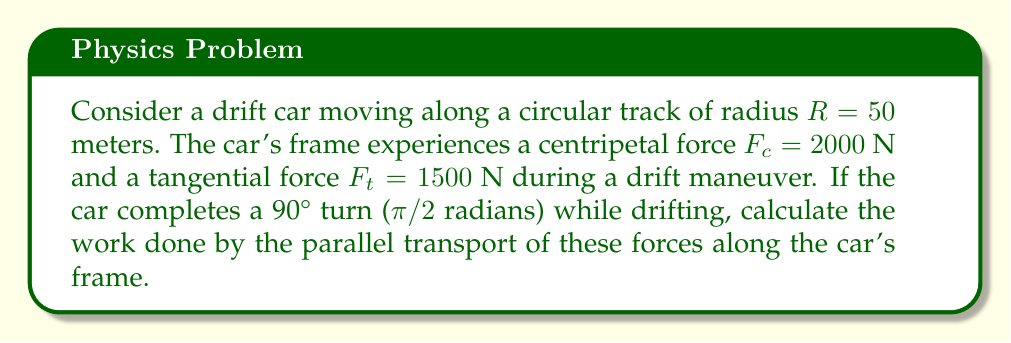Solve this math problem. To solve this problem, we'll use concepts from differential geometry, particularly parallel transport along a curved path. Let's break it down step-by-step:

1) In differential geometry, parallel transport preserves the magnitude of a vector and its angle with the curve. The work done by a force during parallel transport is given by the dot product of the force and the displacement vector.

2) The displacement vector for a 90° turn on a circular track is:
   $$\vec{s} = R\theta\hat{t} = 50 \cdot \frac{\pi}{2}\hat{t} = 25\pi\hat{t}$$
   where $\hat{t}$ is the unit tangent vector.

3) The centripetal force $F_c$ is always perpendicular to the displacement, so it doesn't contribute to the work done.

4) The tangential force $F_t$ is parallel to the displacement and contributes fully to the work done.

5) The work done by the tangential force is:
   $$W = F_t \cdot \vec{s} = 1500 \cdot 25\pi = 37500\pi$$

6) Convert to standard units:
   $$W = 37500\pi \approx 117809.72 \text{ J}$$

Thus, the work done by the parallel transport of forces along the car's frame during the drift maneuver is approximately 117809.72 Joules.
Answer: $117809.72 \text{ J}$ 